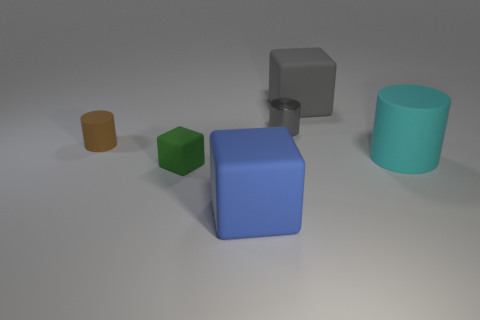Are there any matte blocks of the same color as the small metal cylinder?
Your response must be concise. Yes. What is the shape of the brown thing?
Your response must be concise. Cylinder. There is a small thing in front of the small brown cylinder; is there a rubber cube that is in front of it?
Your response must be concise. Yes. There is a small cylinder in front of the metallic cylinder; how many big gray cubes are in front of it?
Provide a short and direct response. 0. There is a gray cylinder that is the same size as the brown cylinder; what is its material?
Your answer should be very brief. Metal. There is a tiny matte thing that is in front of the brown object; does it have the same shape as the big cyan matte thing?
Offer a very short reply. No. Are there more small things that are in front of the large rubber cylinder than tiny brown cylinders that are in front of the brown cylinder?
Your answer should be compact. Yes. What number of big gray objects have the same material as the blue cube?
Give a very brief answer. 1. Is the gray metallic thing the same size as the brown thing?
Offer a terse response. Yes. The metallic cylinder is what color?
Offer a terse response. Gray. 